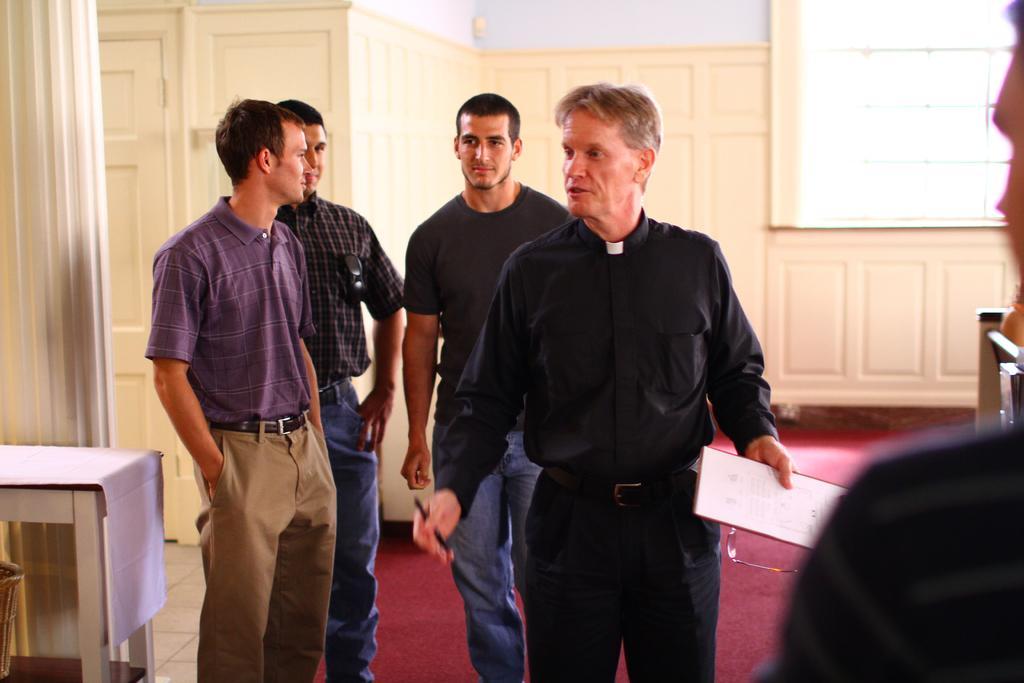Can you describe this image briefly? In this image we can see group of people standing on the floor. One person is holding a paper and spectacles in hand and in other hand he is holding a pen. In the background we can see a person keeping goggles in his pocket ,a table with cloth placed on it and the window. 